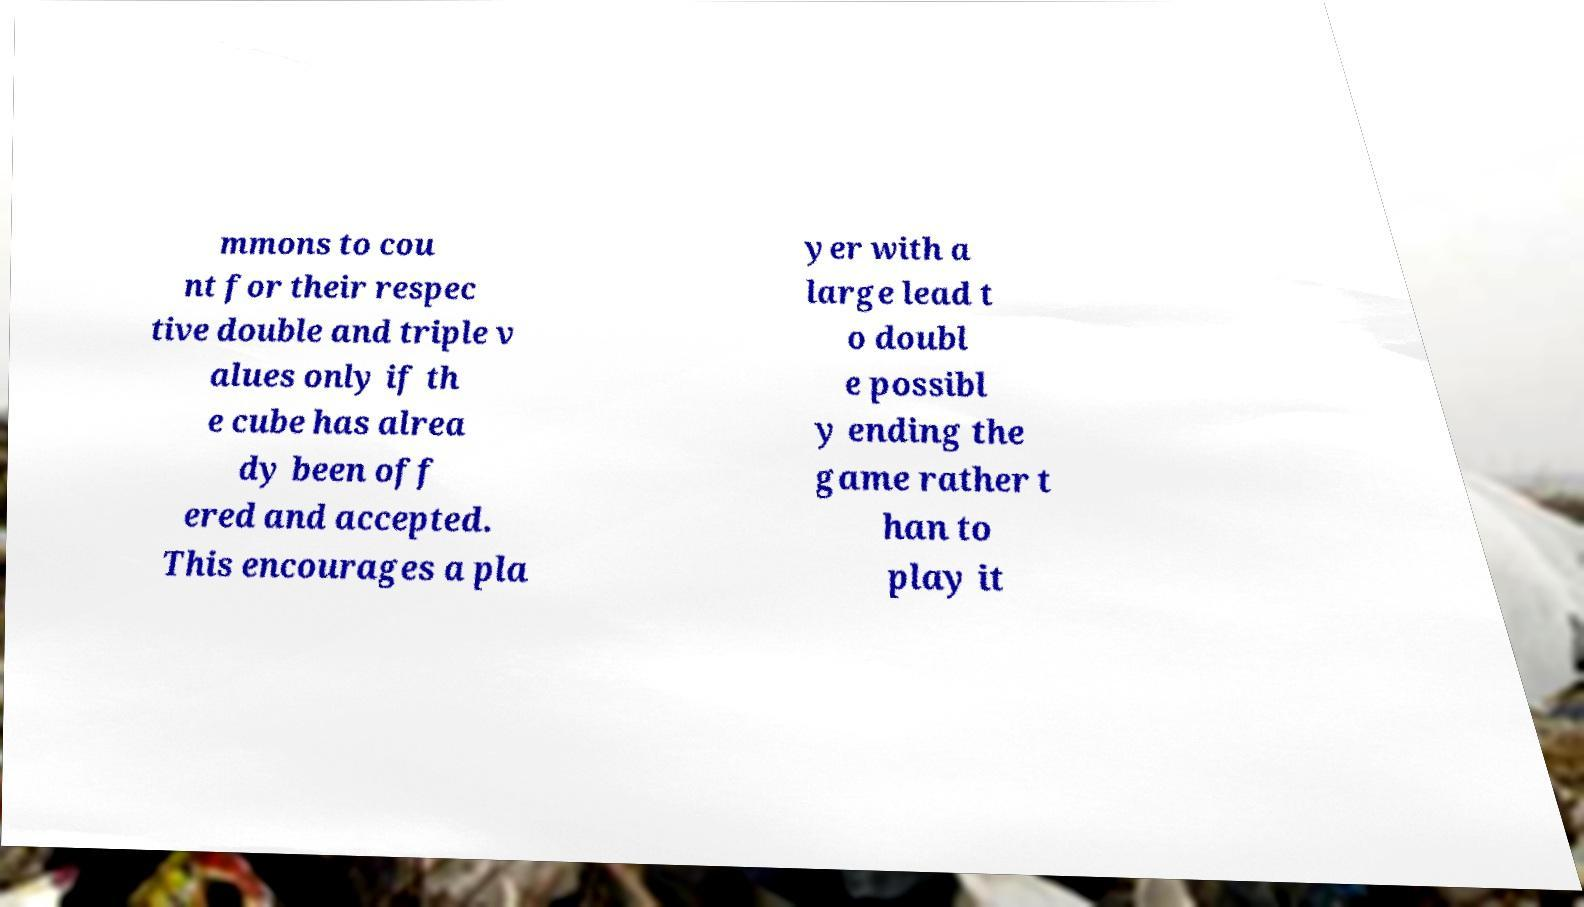Please read and relay the text visible in this image. What does it say? mmons to cou nt for their respec tive double and triple v alues only if th e cube has alrea dy been off ered and accepted. This encourages a pla yer with a large lead t o doubl e possibl y ending the game rather t han to play it 